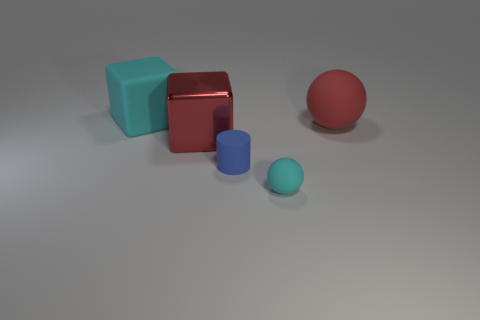What number of tiny balls have the same material as the large red block?
Give a very brief answer. 0. There is a big sphere that is made of the same material as the blue thing; what is its color?
Provide a succinct answer. Red. Is the size of the metallic cube the same as the cyan rubber thing that is on the left side of the tiny cyan rubber object?
Offer a terse response. Yes. The tiny blue object has what shape?
Your response must be concise. Cylinder. How many tiny rubber things are the same color as the tiny cylinder?
Provide a succinct answer. 0. What color is the large rubber thing that is the same shape as the shiny object?
Make the answer very short. Cyan. How many red things are behind the red object that is on the left side of the cyan rubber sphere?
Keep it short and to the point. 1. What number of balls are either big gray matte things or large cyan things?
Make the answer very short. 0. Are any gray shiny cylinders visible?
Make the answer very short. No. What size is the other metallic object that is the same shape as the large cyan thing?
Provide a short and direct response. Large. 